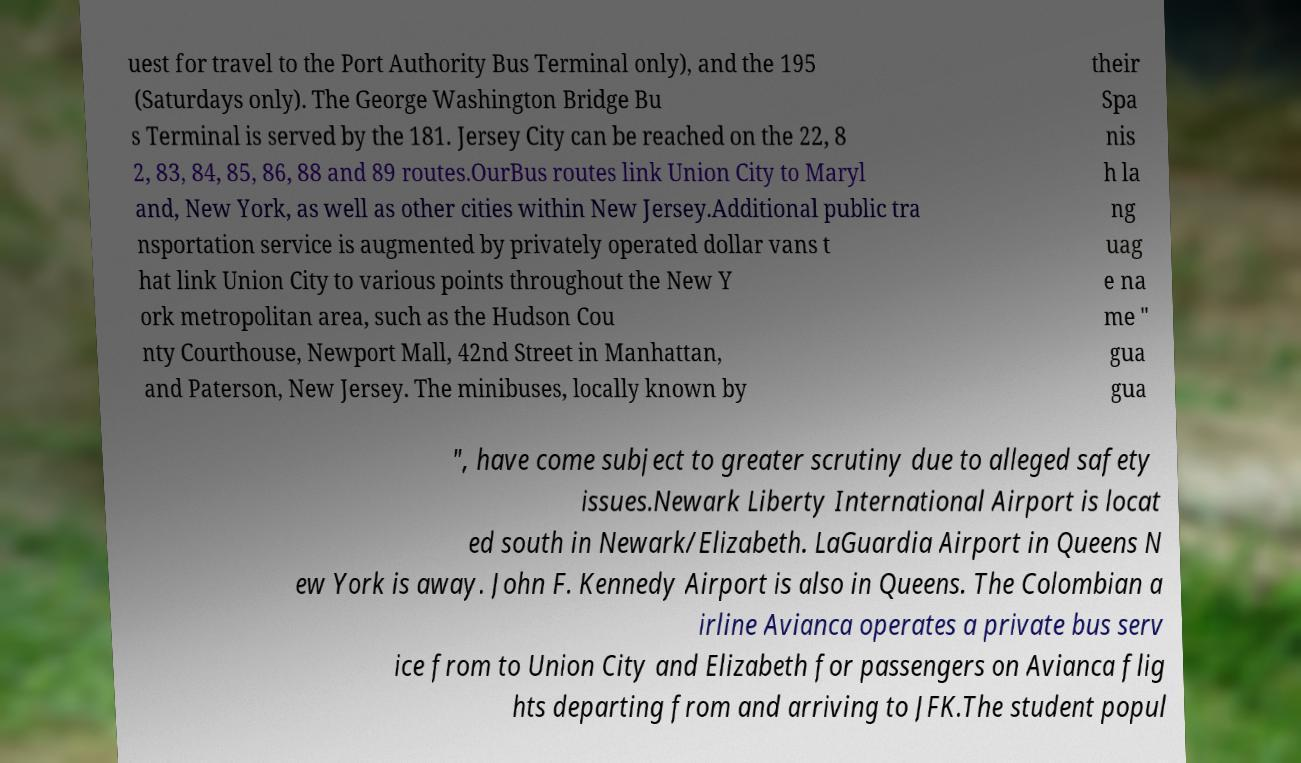There's text embedded in this image that I need extracted. Can you transcribe it verbatim? uest for travel to the Port Authority Bus Terminal only), and the 195 (Saturdays only). The George Washington Bridge Bu s Terminal is served by the 181. Jersey City can be reached on the 22, 8 2, 83, 84, 85, 86, 88 and 89 routes.OurBus routes link Union City to Maryl and, New York, as well as other cities within New Jersey.Additional public tra nsportation service is augmented by privately operated dollar vans t hat link Union City to various points throughout the New Y ork metropolitan area, such as the Hudson Cou nty Courthouse, Newport Mall, 42nd Street in Manhattan, and Paterson, New Jersey. The minibuses, locally known by their Spa nis h la ng uag e na me " gua gua ", have come subject to greater scrutiny due to alleged safety issues.Newark Liberty International Airport is locat ed south in Newark/Elizabeth. LaGuardia Airport in Queens N ew York is away. John F. Kennedy Airport is also in Queens. The Colombian a irline Avianca operates a private bus serv ice from to Union City and Elizabeth for passengers on Avianca flig hts departing from and arriving to JFK.The student popul 